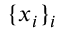Convert formula to latex. <formula><loc_0><loc_0><loc_500><loc_500>\{ x _ { i } \} _ { i }</formula> 